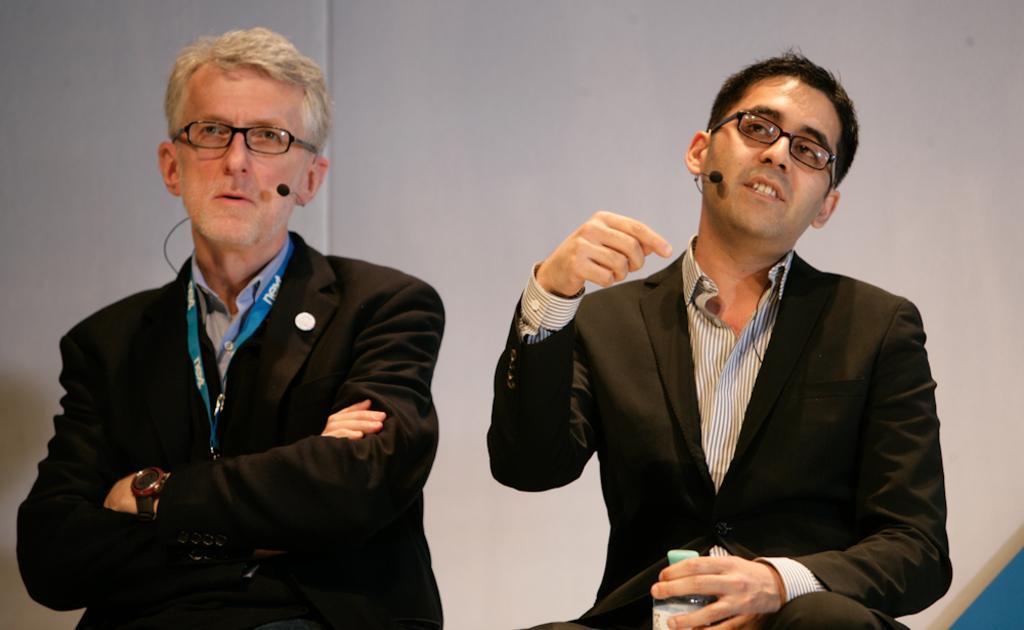Can you describe this image briefly? In this image there are two persons sitting on chairs, in the background there is a wall. 